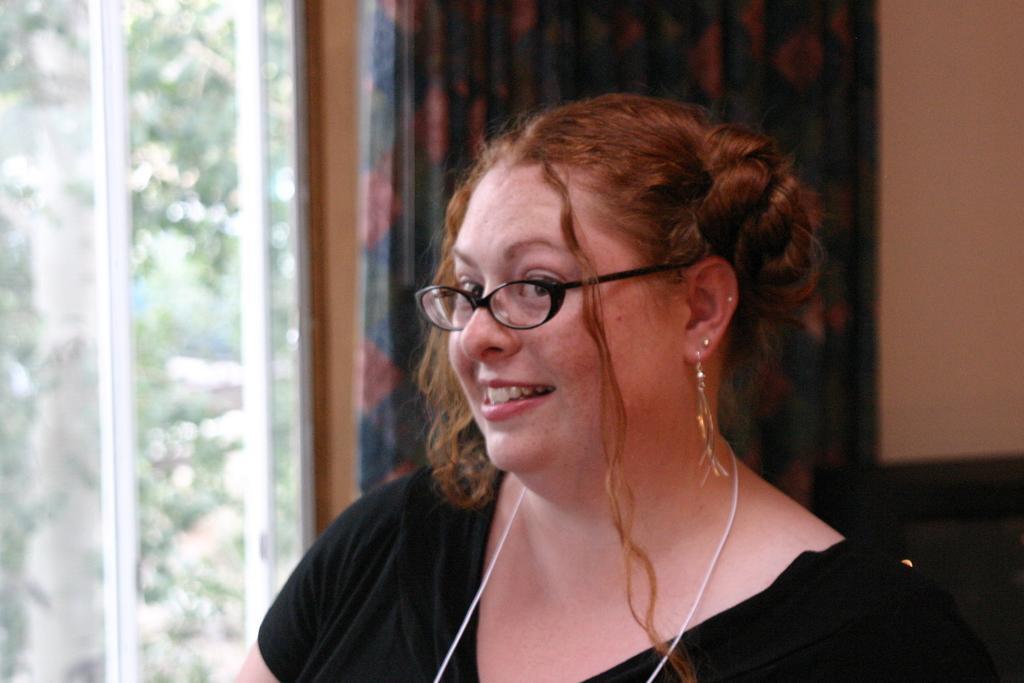Can you describe this image briefly? In this image there is a woman with spectacles is smiling , and in the background there is a curtain, window and a wall. 